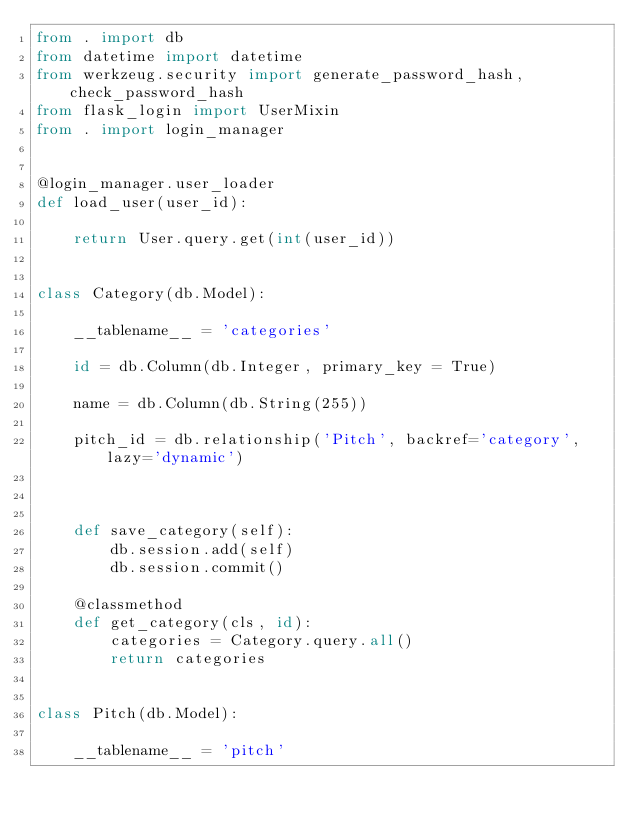Convert code to text. <code><loc_0><loc_0><loc_500><loc_500><_Python_>from . import db
from datetime import datetime
from werkzeug.security import generate_password_hash, check_password_hash
from flask_login import UserMixin
from . import login_manager


@login_manager.user_loader
def load_user(user_id):

    return User.query.get(int(user_id))


class Category(db.Model):

    __tablename__ = 'categories'

    id = db.Column(db.Integer, primary_key = True)

    name = db.Column(db.String(255))

    pitch_id = db.relationship('Pitch', backref='category', lazy='dynamic')



    def save_category(self):
        db.session.add(self)
        db.session.commit()

    @classmethod
    def get_category(cls, id):
        categories = Category.query.all()
        return categories


class Pitch(db.Model):

    __tablename__ = 'pitch'
</code> 